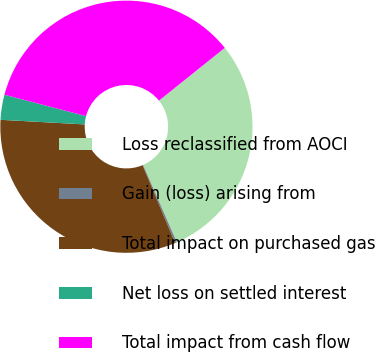Convert chart. <chart><loc_0><loc_0><loc_500><loc_500><pie_chart><fcel>Loss reclassified from AOCI<fcel>Gain (loss) arising from<fcel>Total impact on purchased gas<fcel>Net loss on settled interest<fcel>Total impact from cash flow<nl><fcel>29.21%<fcel>0.23%<fcel>32.19%<fcel>3.21%<fcel>35.17%<nl></chart> 